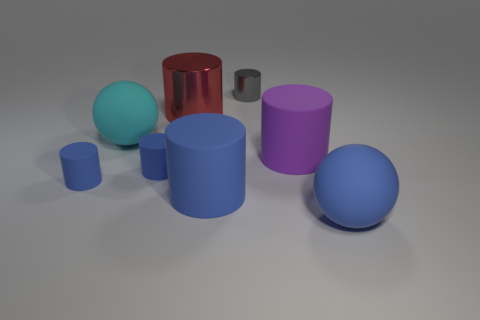Subtract all blue cubes. How many blue cylinders are left? 3 Subtract all large blue cylinders. How many cylinders are left? 5 Subtract all blue cylinders. How many cylinders are left? 3 Add 1 big yellow matte cylinders. How many objects exist? 9 Subtract all cylinders. How many objects are left? 2 Subtract all yellow cylinders. Subtract all gray cubes. How many cylinders are left? 6 Add 7 purple metallic things. How many purple metallic things exist? 7 Subtract 1 red cylinders. How many objects are left? 7 Subtract all gray cylinders. Subtract all big purple shiny objects. How many objects are left? 7 Add 7 tiny blue objects. How many tiny blue objects are left? 9 